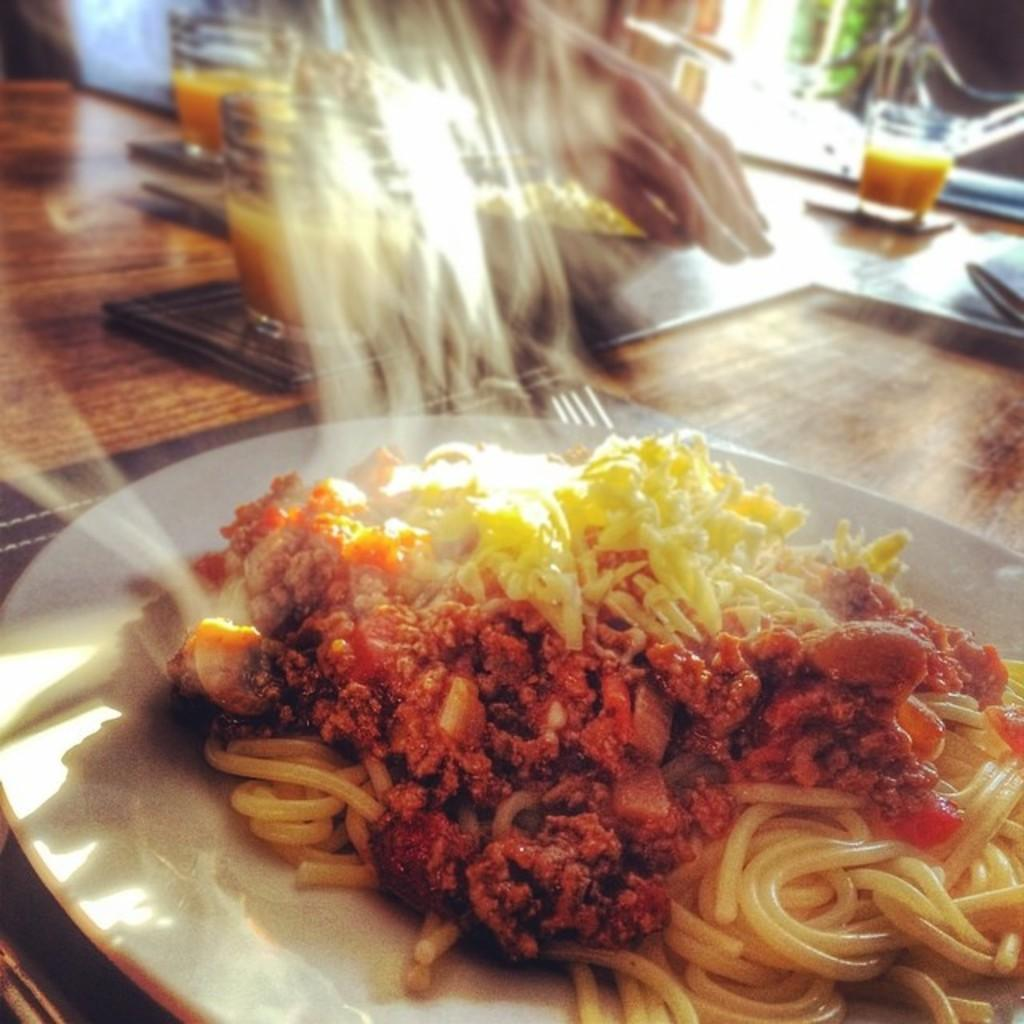What body parts are visible in the image? There are hands visible in the image. What is being held by the hands in the image? There is a bowl of food and a plate of food items in the image. What type of beverages are present in the image? There are glasses of drinks in the image. What type of furniture is present in the image? There is a wooden table in the image. What rhythm is the balloon playing in the image? There is no balloon present in the image, and therefore no rhythm can be associated with it. 